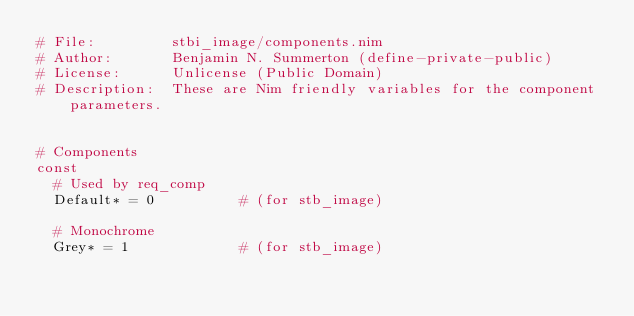Convert code to text. <code><loc_0><loc_0><loc_500><loc_500><_Nim_># File:         stbi_image/components.nim
# Author:       Benjamin N. Summerton (define-private-public)
# License:      Unlicense (Public Domain)
# Description:  These are Nim friendly variables for the component parameters.


# Components
const
  # Used by req_comp
  Default* = 0          # (for stb_image)

  # Monochrome
  Grey* = 1             # (for stb_image)</code> 